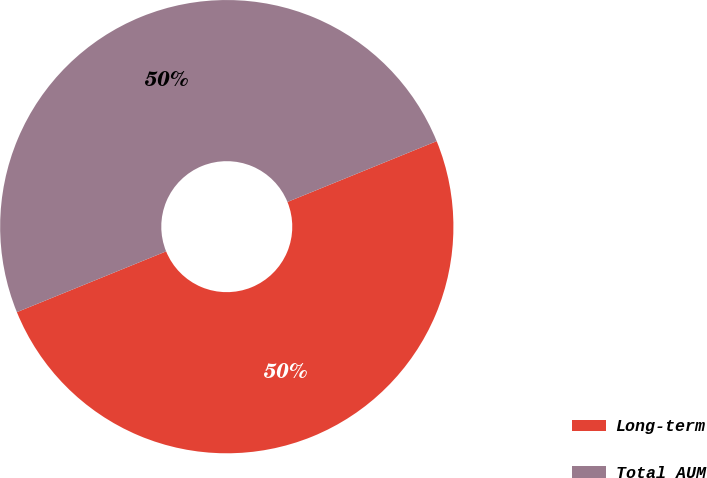Convert chart. <chart><loc_0><loc_0><loc_500><loc_500><pie_chart><fcel>Long-term<fcel>Total AUM<nl><fcel>50.0%<fcel>50.0%<nl></chart> 